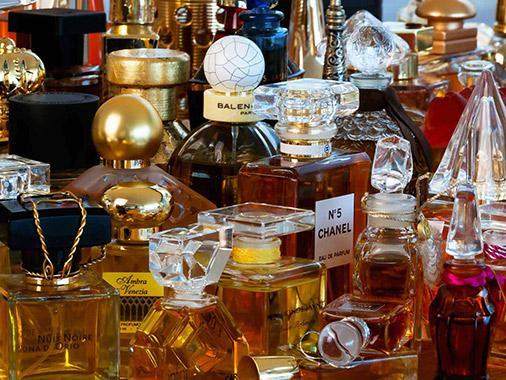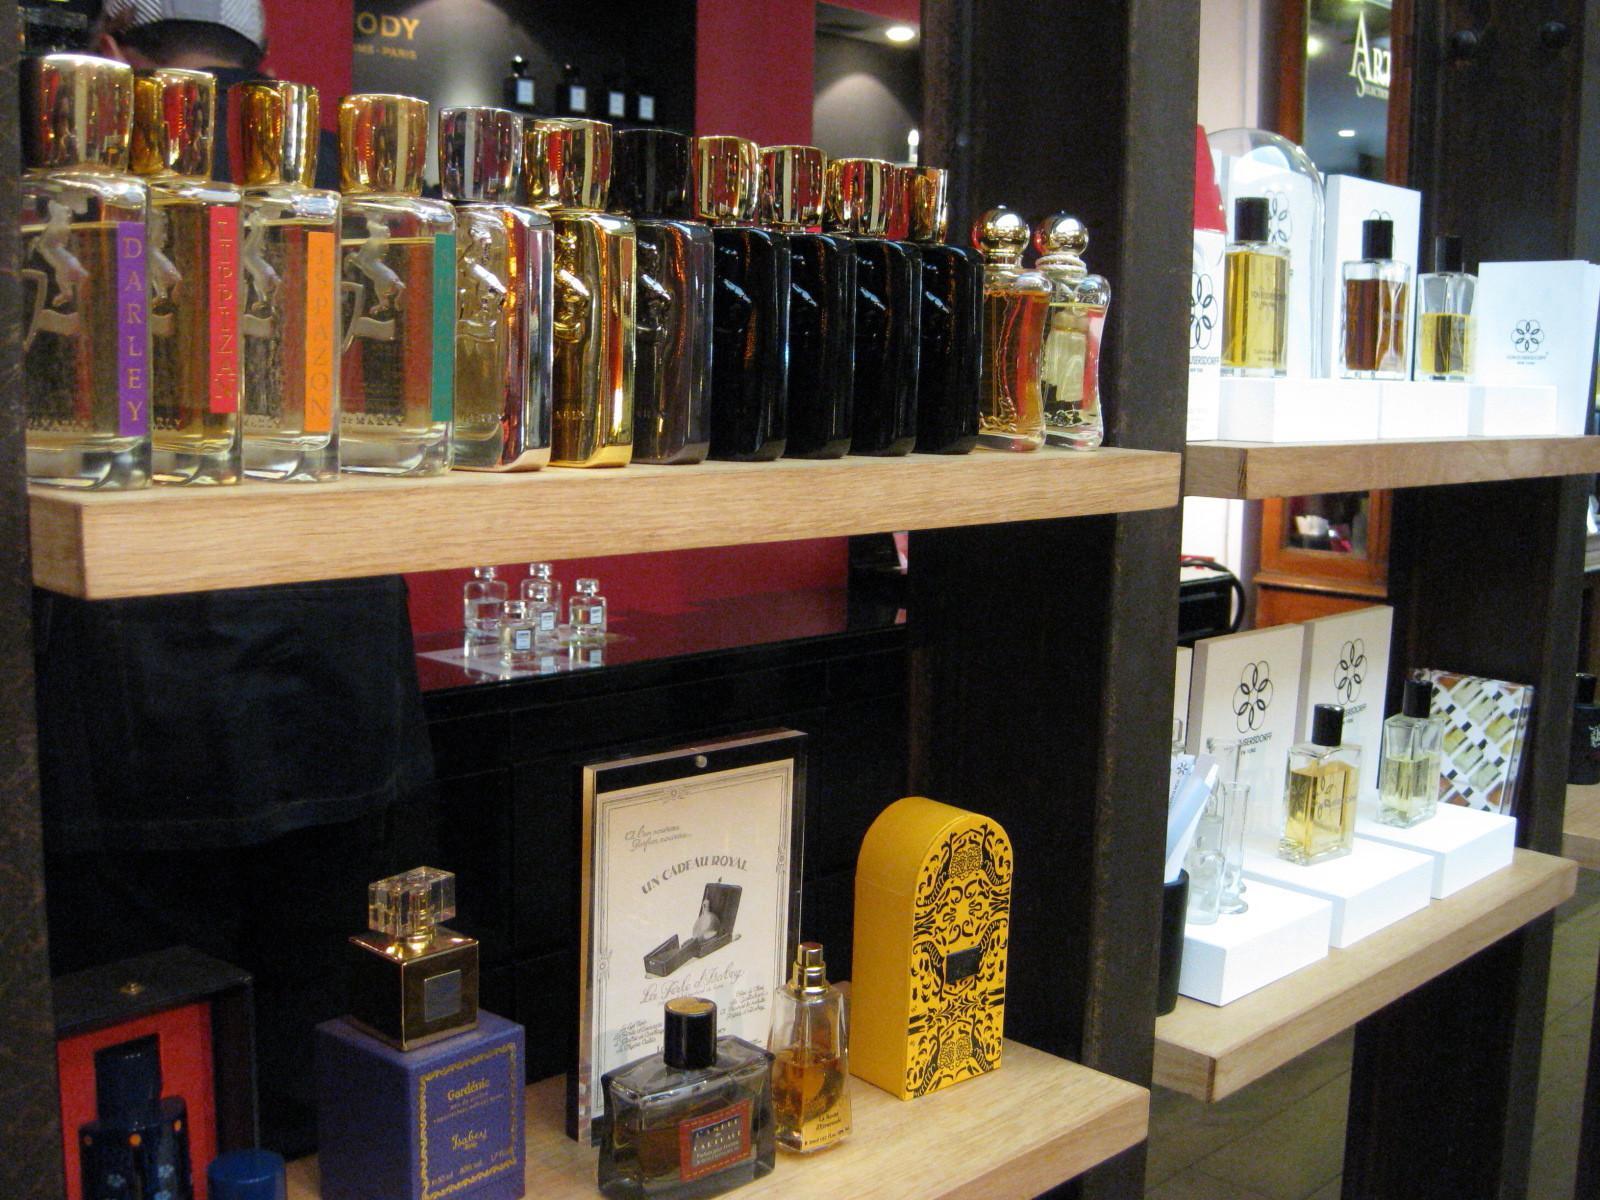The first image is the image on the left, the second image is the image on the right. Examine the images to the left and right. Is the description "One image shows a single squarish bottle to the right of its upright case." accurate? Answer yes or no. No. The first image is the image on the left, the second image is the image on the right. Analyze the images presented: Is the assertion "One of the images shows a single bottle of perfume standing next to its package." valid? Answer yes or no. No. 